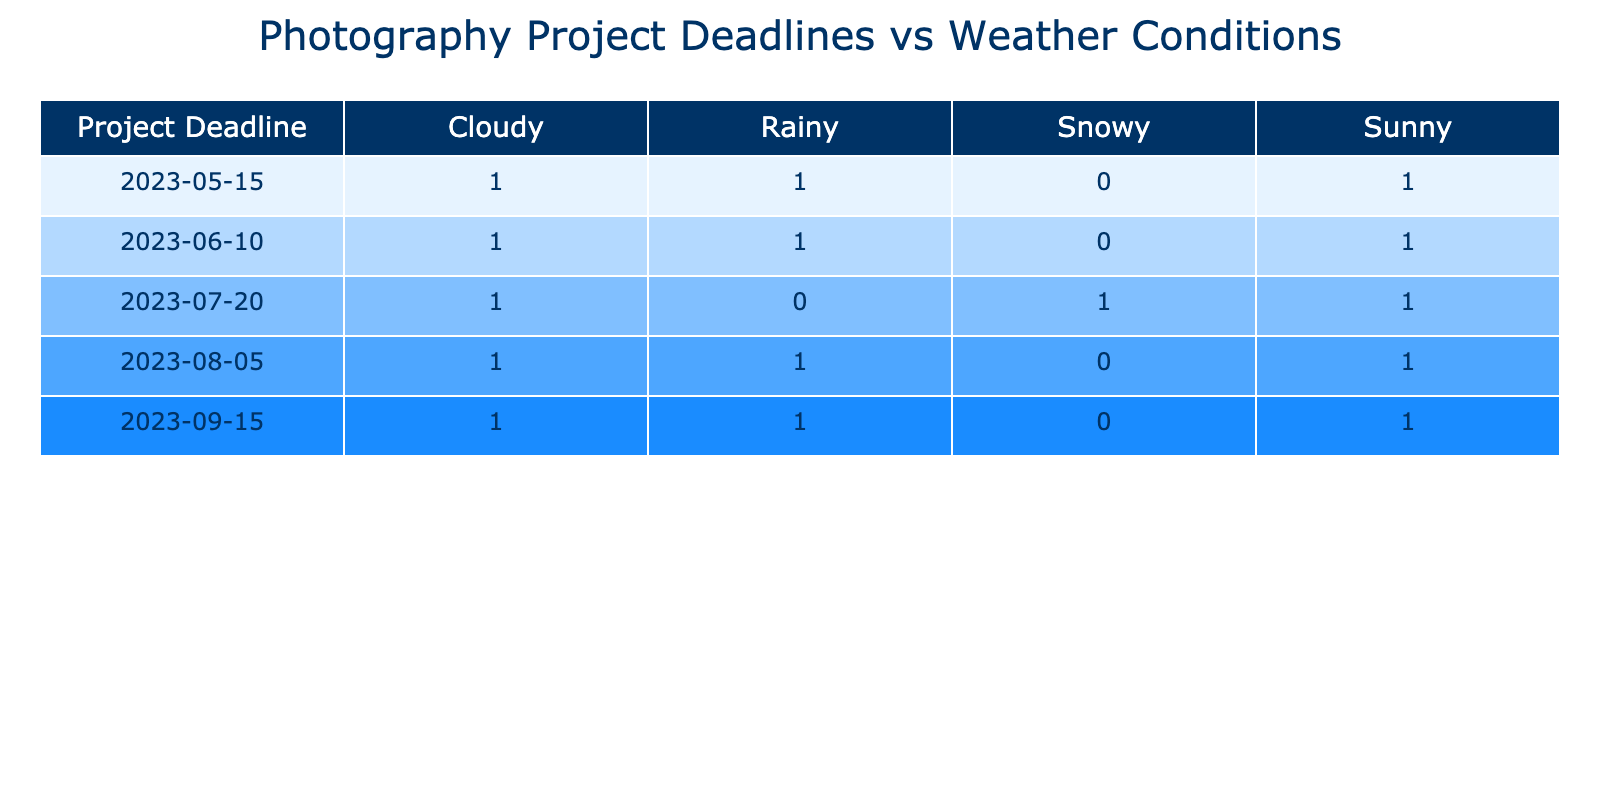What is the total number of photography projects planned for sunny weather? To find the total number of projects planned for sunny weather, we look at the sunny weather conditions and count the number of corresponding project deadlines. These occur on 2023-05-15 (1 project), 2023-06-10 (1 project), 2023-07-20 (1 project), 2023-08-05 (1 project), and 2023-09-15 (1 project). Therefore, the total is 5 projects.
Answer: 5 On which project deadline did the most photographers plan their projects with rainy weather? We check each project deadline for rainy weather and note who the photographers are. The rainy weather is present on 2023-05-15 (1 photographer), 2023-06-10 (1 photographer), 2023-07-20 (0), 2023-08-05 (1 photographer), 2023-09-15 (1 photographer). The maximum is 1 photographer for each deadline with rainy weather.
Answer: 1 Is there any project deadline where both sunny and rainy weather conditions are planned? We can assess each project deadline for the occurrence of both sunny and rainy weather. Checking the deadlines, we find that none of the project deadlines have both sunny and rainy conditions; they either occur separately or are not listed together. Hence, the answer is no.
Answer: No What is the total number of photography projects planned for the month of June? To determine the total projects for June, we count all the projects listed under this month. There are two project deadlines: 2023-06-10 with a sunny condition (1 project) and another with a cloudy condition (1 project), so the total count for June is 2 projects.
Answer: 2 Which location had the highest number of projects with cloudy weather conditions? We examine the project deadlines to check the cloudy weather conditions: on 2023-05-15 (Historic Gardens), 2023-06-10 (Lakeside Park), 2023-07-20 (Historic Gardens), 2023-08-05 (Lakeside Park), and 2023-09-15 (Winter Wonderland). Lakeside Park has cloudy conditions in June and August (2 projects) while Historic Gardens has 2 (May and July). Therefore, both locations have an equal number of projects.
Answer: Historic Gardens and Lakeside Park What is the ratio of projects planned for sunny weather to those for rainy weather across all deadlines? We gather the total number of projects for sunny and rainy weather conditions. Sunny projects total 5 and rainy projects total 4. To get the ratio, we divide the number of sunny projects by rainy projects: 5 sunny projects: 4 rainy projects equates to a ratio of 5:4.
Answer: 5:4 On which specific date did Jessica Lee plan her photography project? By looking at the table, we search for Jessica Lee's name in the photographer column. She is noted to have a project with a rainy condition on the date of 2023-06-10.
Answer: 2023-06-10 Did any project deadlines have snow as a weather condition? We look through the table to identify if any project deadlines are associated with snowy weather. The only entry showing snow is on 2023-07-20, indicating that there is indeed a project deadline with snowy conditions.
Answer: Yes What is the average number of projects per weather condition across all deadlines? To calculate the average, we first sum the number of projects per weather condition: sunny (5), cloudy (4), rainy (4), snowy (1). This gives a total of 14 projects. Since there are 4 distinct weather conditions, we divide 14 by 4. Hence, the average is 3.5 projects per weather condition.
Answer: 3.5 